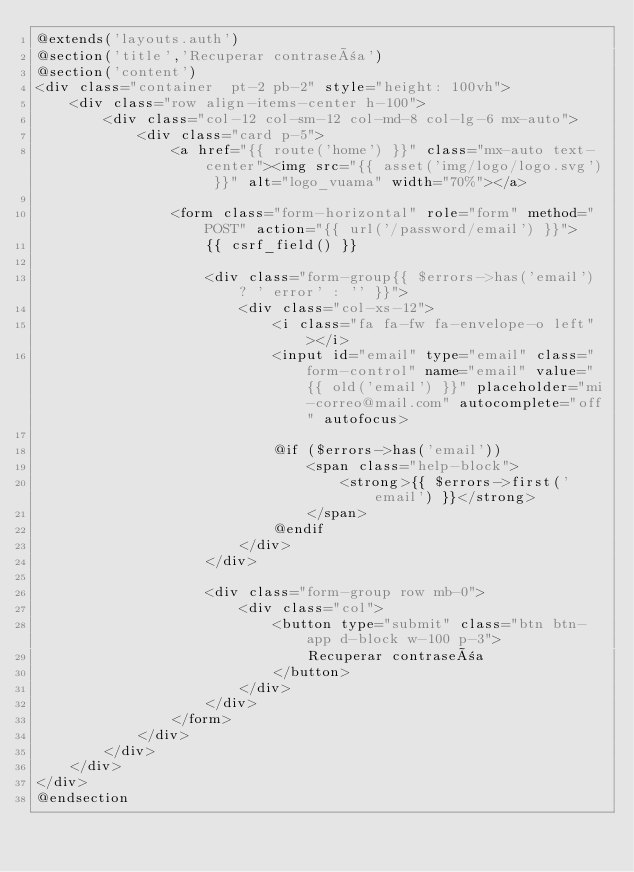Convert code to text. <code><loc_0><loc_0><loc_500><loc_500><_PHP_>@extends('layouts.auth')
@section('title','Recuperar contraseña')
@section('content')
<div class="container  pt-2 pb-2" style="height: 100vh">
    <div class="row align-items-center h-100">
        <div class="col-12 col-sm-12 col-md-8 col-lg-6 mx-auto">
            <div class="card p-5">
                <a href="{{ route('home') }}" class="mx-auto text-center"><img src="{{ asset('img/logo/logo.svg') }}" alt="logo_vuama" width="70%"></a>
                    
                <form class="form-horizontal" role="form" method="POST" action="{{ url('/password/email') }}">
                    {{ csrf_field() }}

                    <div class="form-group{{ $errors->has('email') ? ' error' : '' }}">
                        <div class="col-xs-12">
                            <i class="fa fa-fw fa-envelope-o left"></i>
                            <input id="email" type="email" class="form-control" name="email" value="{{ old('email') }}" placeholder="mi-correo@mail.com" autocomplete="off" autofocus>

                            @if ($errors->has('email'))
                                <span class="help-block">
                                    <strong>{{ $errors->first('email') }}</strong>
                                </span>
                            @endif
                        </div>
                    </div>

                    <div class="form-group row mb-0">
                        <div class="col">
                            <button type="submit" class="btn btn-app d-block w-100 p-3">
                                Recuperar contraseña
                            </button>
                        </div>
                    </div>
                </form>
            </div>
        </div>
    </div>
</div>
@endsection
</code> 